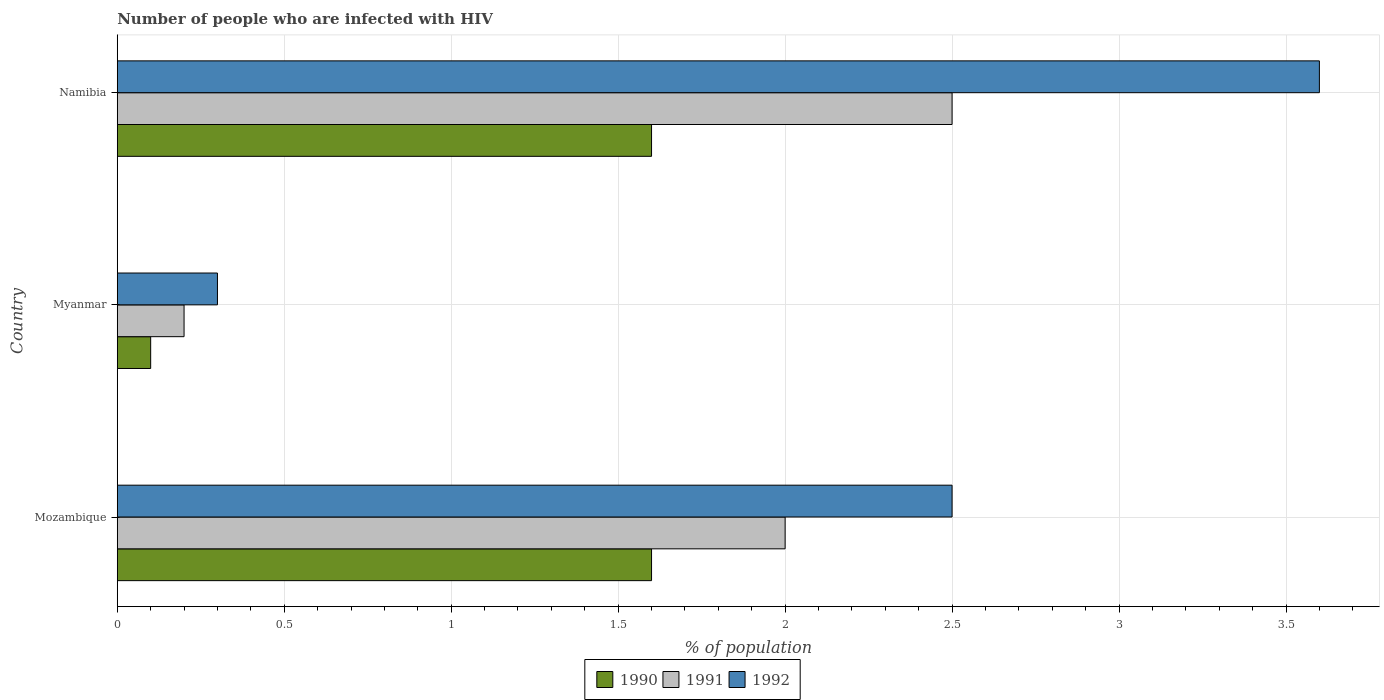Are the number of bars per tick equal to the number of legend labels?
Make the answer very short. Yes. Are the number of bars on each tick of the Y-axis equal?
Provide a succinct answer. Yes. How many bars are there on the 2nd tick from the bottom?
Your response must be concise. 3. What is the label of the 3rd group of bars from the top?
Your answer should be very brief. Mozambique. In which country was the percentage of HIV infected population in in 1991 maximum?
Your answer should be compact. Namibia. In which country was the percentage of HIV infected population in in 1991 minimum?
Your response must be concise. Myanmar. What is the difference between the percentage of HIV infected population in in 1991 in Myanmar and that in Namibia?
Make the answer very short. -2.3. What is the difference between the percentage of HIV infected population in in 1990 in Namibia and the percentage of HIV infected population in in 1991 in Myanmar?
Offer a terse response. 1.4. What is the average percentage of HIV infected population in in 1991 per country?
Keep it short and to the point. 1.57. What is the difference between the percentage of HIV infected population in in 1992 and percentage of HIV infected population in in 1990 in Myanmar?
Offer a terse response. 0.2. In how many countries, is the percentage of HIV infected population in in 1992 greater than 2.4 %?
Give a very brief answer. 2. What is the ratio of the percentage of HIV infected population in in 1990 in Myanmar to that in Namibia?
Provide a succinct answer. 0.06. What is the difference between the highest and the second highest percentage of HIV infected population in in 1990?
Offer a very short reply. 0. Are all the bars in the graph horizontal?
Your response must be concise. Yes. How many countries are there in the graph?
Your response must be concise. 3. What is the difference between two consecutive major ticks on the X-axis?
Provide a succinct answer. 0.5. Are the values on the major ticks of X-axis written in scientific E-notation?
Your answer should be very brief. No. Does the graph contain grids?
Give a very brief answer. Yes. Where does the legend appear in the graph?
Keep it short and to the point. Bottom center. How many legend labels are there?
Your response must be concise. 3. What is the title of the graph?
Keep it short and to the point. Number of people who are infected with HIV. What is the label or title of the X-axis?
Offer a very short reply. % of population. What is the % of population in 1990 in Mozambique?
Make the answer very short. 1.6. What is the % of population in 1992 in Mozambique?
Offer a very short reply. 2.5. What is the % of population of 1992 in Myanmar?
Your response must be concise. 0.3. What is the % of population in 1991 in Namibia?
Your response must be concise. 2.5. Across all countries, what is the maximum % of population in 1991?
Your answer should be compact. 2.5. Across all countries, what is the minimum % of population in 1992?
Provide a succinct answer. 0.3. What is the difference between the % of population in 1991 in Mozambique and that in Myanmar?
Provide a short and direct response. 1.8. What is the difference between the % of population of 1992 in Mozambique and that in Myanmar?
Your answer should be very brief. 2.2. What is the difference between the % of population in 1991 in Mozambique and that in Namibia?
Offer a terse response. -0.5. What is the difference between the % of population of 1990 in Myanmar and that in Namibia?
Provide a succinct answer. -1.5. What is the difference between the % of population of 1991 in Mozambique and the % of population of 1992 in Myanmar?
Offer a very short reply. 1.7. What is the difference between the % of population of 1991 in Mozambique and the % of population of 1992 in Namibia?
Provide a short and direct response. -1.6. What is the difference between the % of population of 1990 in Myanmar and the % of population of 1991 in Namibia?
Your answer should be compact. -2.4. What is the difference between the % of population in 1990 in Myanmar and the % of population in 1992 in Namibia?
Provide a short and direct response. -3.5. What is the average % of population of 1991 per country?
Offer a terse response. 1.57. What is the average % of population in 1992 per country?
Offer a very short reply. 2.13. What is the difference between the % of population in 1990 and % of population in 1991 in Mozambique?
Provide a short and direct response. -0.4. What is the difference between the % of population of 1990 and % of population of 1992 in Mozambique?
Ensure brevity in your answer.  -0.9. What is the difference between the % of population of 1990 and % of population of 1991 in Myanmar?
Provide a succinct answer. -0.1. What is the difference between the % of population in 1991 and % of population in 1992 in Namibia?
Provide a short and direct response. -1.1. What is the ratio of the % of population in 1992 in Mozambique to that in Myanmar?
Offer a very short reply. 8.33. What is the ratio of the % of population of 1990 in Mozambique to that in Namibia?
Provide a short and direct response. 1. What is the ratio of the % of population of 1992 in Mozambique to that in Namibia?
Your answer should be very brief. 0.69. What is the ratio of the % of population of 1990 in Myanmar to that in Namibia?
Offer a terse response. 0.06. What is the ratio of the % of population of 1991 in Myanmar to that in Namibia?
Make the answer very short. 0.08. What is the ratio of the % of population in 1992 in Myanmar to that in Namibia?
Provide a short and direct response. 0.08. What is the difference between the highest and the second highest % of population of 1992?
Your response must be concise. 1.1. What is the difference between the highest and the lowest % of population of 1990?
Your response must be concise. 1.5. What is the difference between the highest and the lowest % of population of 1991?
Your answer should be very brief. 2.3. 